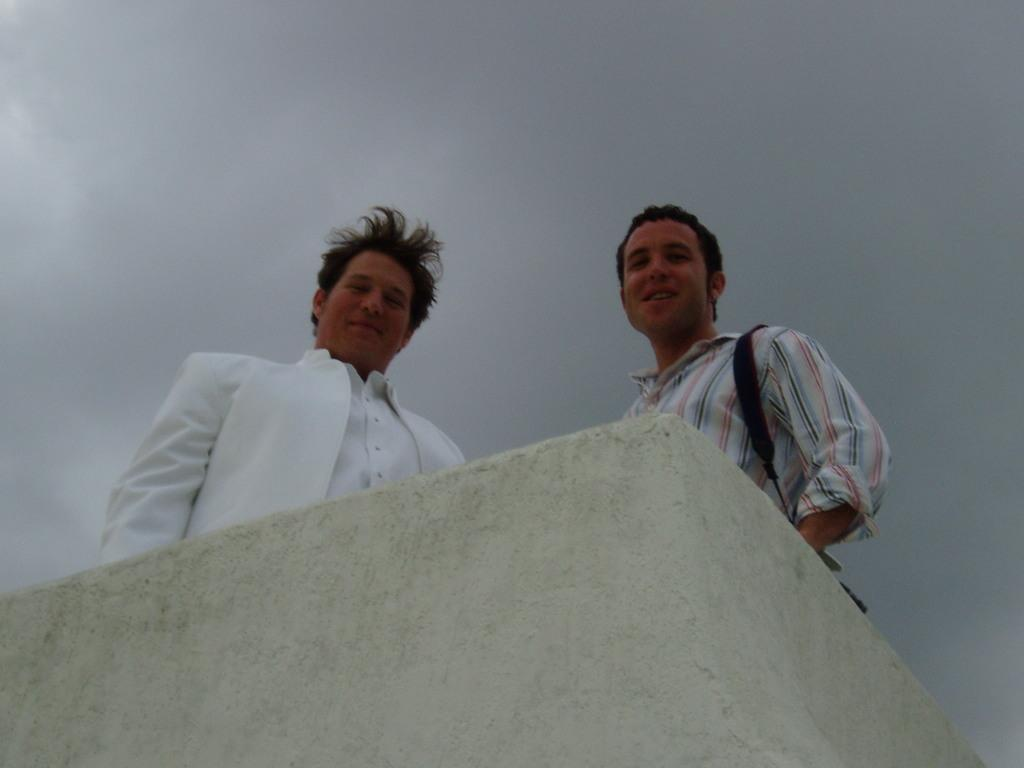What is located at the bottom of the image? There is a wall at the bottom of the image. What can be seen behind the wall? There are two men standing behind the wall. What is the facial expression of the men? The men are smiling. What is visible at the top of the image? The sky is visible at the top of the image. What type of weather can be inferred from the sky? Clouds are present in the sky, suggesting a partly cloudy day. How many thumbs can be seen on the men in the image? There is no information about the men's thumbs in the image, so it cannot be determined. What type of fowl is flying in the sky in the image? There is no fowl visible in the sky in the image. 